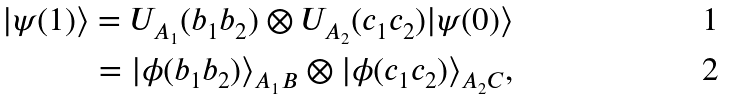Convert formula to latex. <formula><loc_0><loc_0><loc_500><loc_500>| \psi ( 1 ) \rangle = U _ { A _ { 1 } } ( b _ { 1 } b _ { 2 } ) \otimes U _ { A _ { 2 } } ( c _ { 1 } c _ { 2 } ) | \psi ( 0 ) \rangle \\ = | \phi ( b _ { 1 } b _ { 2 } ) \rangle _ { A _ { 1 } B } \otimes | \phi ( c _ { 1 } c _ { 2 } ) \rangle _ { A _ { 2 } C } ,</formula> 